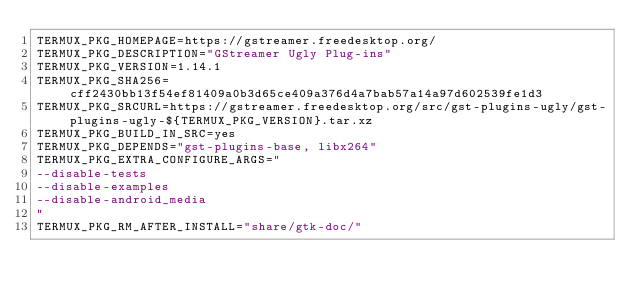<code> <loc_0><loc_0><loc_500><loc_500><_Bash_>TERMUX_PKG_HOMEPAGE=https://gstreamer.freedesktop.org/
TERMUX_PKG_DESCRIPTION="GStreamer Ugly Plug-ins"
TERMUX_PKG_VERSION=1.14.1
TERMUX_PKG_SHA256=cff2430bb13f54ef81409a0b3d65ce409a376d4a7bab57a14a97d602539fe1d3
TERMUX_PKG_SRCURL=https://gstreamer.freedesktop.org/src/gst-plugins-ugly/gst-plugins-ugly-${TERMUX_PKG_VERSION}.tar.xz
TERMUX_PKG_BUILD_IN_SRC=yes
TERMUX_PKG_DEPENDS="gst-plugins-base, libx264"
TERMUX_PKG_EXTRA_CONFIGURE_ARGS="
--disable-tests
--disable-examples
--disable-android_media
"
TERMUX_PKG_RM_AFTER_INSTALL="share/gtk-doc/"
</code> 